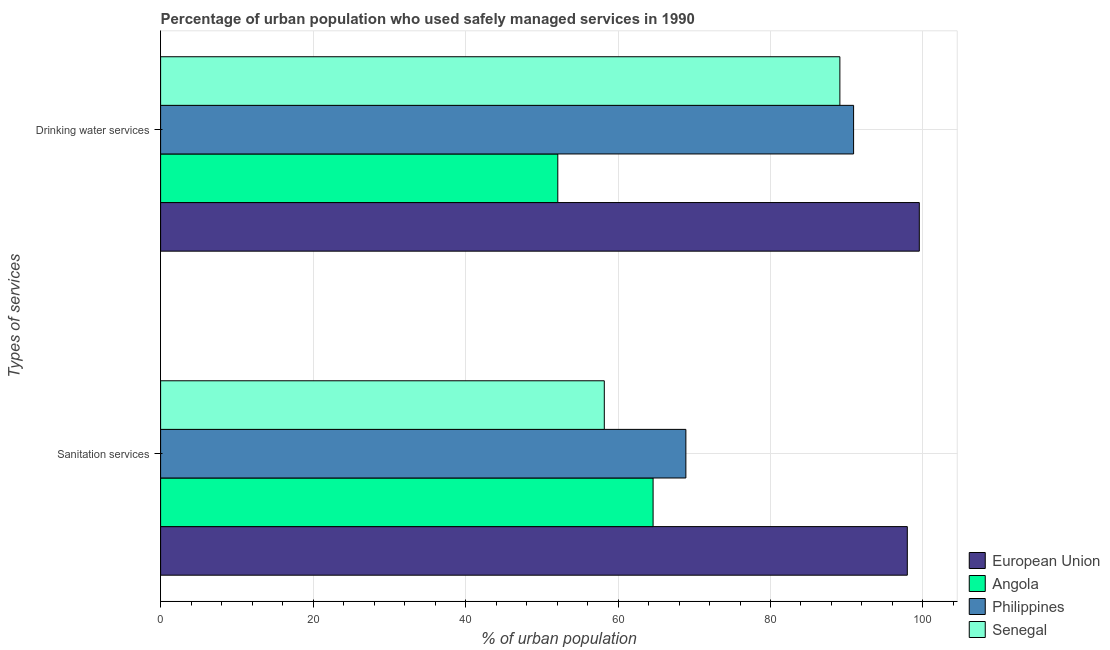Are the number of bars per tick equal to the number of legend labels?
Keep it short and to the point. Yes. Are the number of bars on each tick of the Y-axis equal?
Your answer should be compact. Yes. What is the label of the 2nd group of bars from the top?
Offer a very short reply. Sanitation services. What is the percentage of urban population who used sanitation services in Senegal?
Your response must be concise. 58.2. Across all countries, what is the maximum percentage of urban population who used drinking water services?
Make the answer very short. 99.52. Across all countries, what is the minimum percentage of urban population who used drinking water services?
Make the answer very short. 52.1. In which country was the percentage of urban population who used drinking water services maximum?
Offer a very short reply. European Union. In which country was the percentage of urban population who used sanitation services minimum?
Keep it short and to the point. Senegal. What is the total percentage of urban population who used sanitation services in the graph?
Your answer should be very brief. 289.65. What is the difference between the percentage of urban population who used drinking water services in Philippines and that in Angola?
Your answer should be very brief. 38.8. What is the difference between the percentage of urban population who used drinking water services in European Union and the percentage of urban population who used sanitation services in Philippines?
Ensure brevity in your answer.  30.62. What is the average percentage of urban population who used drinking water services per country?
Your answer should be very brief. 82.9. In how many countries, is the percentage of urban population who used drinking water services greater than 76 %?
Your answer should be compact. 3. What is the ratio of the percentage of urban population who used drinking water services in Philippines to that in Senegal?
Provide a succinct answer. 1.02. In how many countries, is the percentage of urban population who used drinking water services greater than the average percentage of urban population who used drinking water services taken over all countries?
Your answer should be very brief. 3. What does the 1st bar from the top in Sanitation services represents?
Ensure brevity in your answer.  Senegal. What does the 2nd bar from the bottom in Drinking water services represents?
Your response must be concise. Angola. How many bars are there?
Offer a terse response. 8. What is the difference between two consecutive major ticks on the X-axis?
Your answer should be compact. 20. Are the values on the major ticks of X-axis written in scientific E-notation?
Ensure brevity in your answer.  No. Does the graph contain any zero values?
Your answer should be very brief. No. Does the graph contain grids?
Your answer should be compact. Yes. Where does the legend appear in the graph?
Your answer should be compact. Bottom right. What is the title of the graph?
Give a very brief answer. Percentage of urban population who used safely managed services in 1990. Does "Singapore" appear as one of the legend labels in the graph?
Offer a very short reply. No. What is the label or title of the X-axis?
Your answer should be very brief. % of urban population. What is the label or title of the Y-axis?
Offer a very short reply. Types of services. What is the % of urban population in European Union in Sanitation services?
Keep it short and to the point. 97.95. What is the % of urban population in Angola in Sanitation services?
Your answer should be compact. 64.6. What is the % of urban population in Philippines in Sanitation services?
Keep it short and to the point. 68.9. What is the % of urban population in Senegal in Sanitation services?
Make the answer very short. 58.2. What is the % of urban population in European Union in Drinking water services?
Provide a short and direct response. 99.52. What is the % of urban population of Angola in Drinking water services?
Offer a very short reply. 52.1. What is the % of urban population in Philippines in Drinking water services?
Your answer should be very brief. 90.9. What is the % of urban population in Senegal in Drinking water services?
Your answer should be very brief. 89.1. Across all Types of services, what is the maximum % of urban population of European Union?
Your response must be concise. 99.52. Across all Types of services, what is the maximum % of urban population in Angola?
Ensure brevity in your answer.  64.6. Across all Types of services, what is the maximum % of urban population in Philippines?
Ensure brevity in your answer.  90.9. Across all Types of services, what is the maximum % of urban population of Senegal?
Give a very brief answer. 89.1. Across all Types of services, what is the minimum % of urban population in European Union?
Your response must be concise. 97.95. Across all Types of services, what is the minimum % of urban population of Angola?
Ensure brevity in your answer.  52.1. Across all Types of services, what is the minimum % of urban population of Philippines?
Provide a short and direct response. 68.9. Across all Types of services, what is the minimum % of urban population of Senegal?
Offer a terse response. 58.2. What is the total % of urban population in European Union in the graph?
Your answer should be very brief. 197.47. What is the total % of urban population in Angola in the graph?
Your answer should be very brief. 116.7. What is the total % of urban population of Philippines in the graph?
Your response must be concise. 159.8. What is the total % of urban population in Senegal in the graph?
Make the answer very short. 147.3. What is the difference between the % of urban population in European Union in Sanitation services and that in Drinking water services?
Provide a short and direct response. -1.57. What is the difference between the % of urban population in Philippines in Sanitation services and that in Drinking water services?
Give a very brief answer. -22. What is the difference between the % of urban population of Senegal in Sanitation services and that in Drinking water services?
Provide a succinct answer. -30.9. What is the difference between the % of urban population of European Union in Sanitation services and the % of urban population of Angola in Drinking water services?
Keep it short and to the point. 45.85. What is the difference between the % of urban population in European Union in Sanitation services and the % of urban population in Philippines in Drinking water services?
Provide a short and direct response. 7.05. What is the difference between the % of urban population in European Union in Sanitation services and the % of urban population in Senegal in Drinking water services?
Provide a short and direct response. 8.85. What is the difference between the % of urban population in Angola in Sanitation services and the % of urban population in Philippines in Drinking water services?
Give a very brief answer. -26.3. What is the difference between the % of urban population in Angola in Sanitation services and the % of urban population in Senegal in Drinking water services?
Make the answer very short. -24.5. What is the difference between the % of urban population of Philippines in Sanitation services and the % of urban population of Senegal in Drinking water services?
Your answer should be compact. -20.2. What is the average % of urban population in European Union per Types of services?
Offer a very short reply. 98.73. What is the average % of urban population in Angola per Types of services?
Keep it short and to the point. 58.35. What is the average % of urban population of Philippines per Types of services?
Your response must be concise. 79.9. What is the average % of urban population in Senegal per Types of services?
Your answer should be compact. 73.65. What is the difference between the % of urban population of European Union and % of urban population of Angola in Sanitation services?
Your answer should be very brief. 33.35. What is the difference between the % of urban population in European Union and % of urban population in Philippines in Sanitation services?
Provide a short and direct response. 29.05. What is the difference between the % of urban population in European Union and % of urban population in Senegal in Sanitation services?
Provide a succinct answer. 39.75. What is the difference between the % of urban population in European Union and % of urban population in Angola in Drinking water services?
Provide a short and direct response. 47.42. What is the difference between the % of urban population in European Union and % of urban population in Philippines in Drinking water services?
Provide a short and direct response. 8.62. What is the difference between the % of urban population in European Union and % of urban population in Senegal in Drinking water services?
Your answer should be very brief. 10.42. What is the difference between the % of urban population in Angola and % of urban population in Philippines in Drinking water services?
Provide a succinct answer. -38.8. What is the difference between the % of urban population in Angola and % of urban population in Senegal in Drinking water services?
Your response must be concise. -37. What is the difference between the % of urban population of Philippines and % of urban population of Senegal in Drinking water services?
Make the answer very short. 1.8. What is the ratio of the % of urban population of European Union in Sanitation services to that in Drinking water services?
Ensure brevity in your answer.  0.98. What is the ratio of the % of urban population in Angola in Sanitation services to that in Drinking water services?
Provide a short and direct response. 1.24. What is the ratio of the % of urban population of Philippines in Sanitation services to that in Drinking water services?
Offer a terse response. 0.76. What is the ratio of the % of urban population in Senegal in Sanitation services to that in Drinking water services?
Give a very brief answer. 0.65. What is the difference between the highest and the second highest % of urban population of European Union?
Ensure brevity in your answer.  1.57. What is the difference between the highest and the second highest % of urban population in Senegal?
Keep it short and to the point. 30.9. What is the difference between the highest and the lowest % of urban population in European Union?
Provide a succinct answer. 1.57. What is the difference between the highest and the lowest % of urban population in Senegal?
Provide a succinct answer. 30.9. 